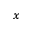<formula> <loc_0><loc_0><loc_500><loc_500>_ { x }</formula> 